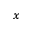<formula> <loc_0><loc_0><loc_500><loc_500>_ { x }</formula> 